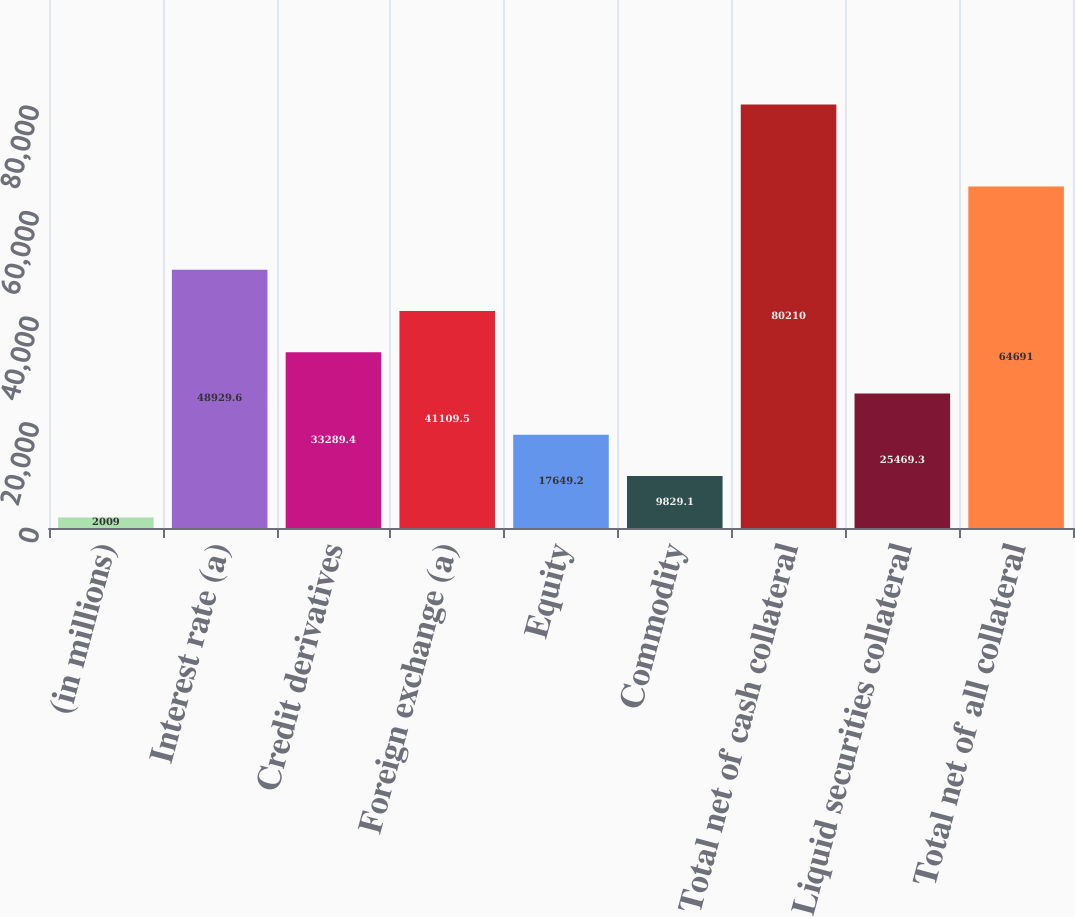Convert chart. <chart><loc_0><loc_0><loc_500><loc_500><bar_chart><fcel>(in millions)<fcel>Interest rate (a)<fcel>Credit derivatives<fcel>Foreign exchange (a)<fcel>Equity<fcel>Commodity<fcel>Total net of cash collateral<fcel>Liquid securities collateral<fcel>Total net of all collateral<nl><fcel>2009<fcel>48929.6<fcel>33289.4<fcel>41109.5<fcel>17649.2<fcel>9829.1<fcel>80210<fcel>25469.3<fcel>64691<nl></chart> 